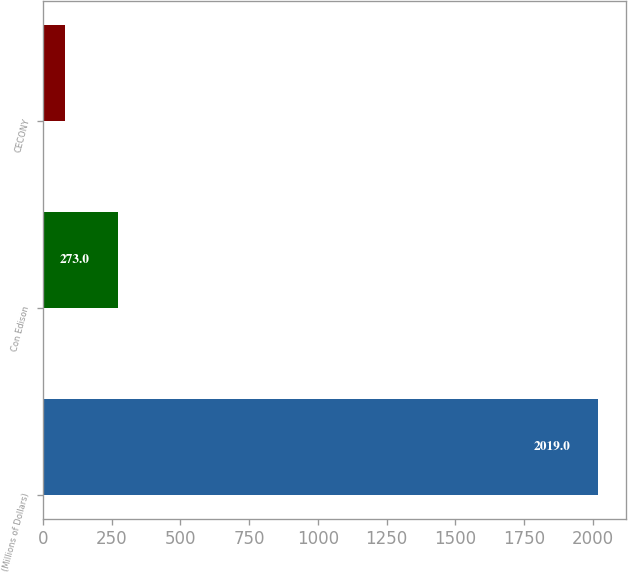Convert chart to OTSL. <chart><loc_0><loc_0><loc_500><loc_500><bar_chart><fcel>(Millions of Dollars)<fcel>Con Edison<fcel>CECONY<nl><fcel>2019<fcel>273<fcel>79<nl></chart> 